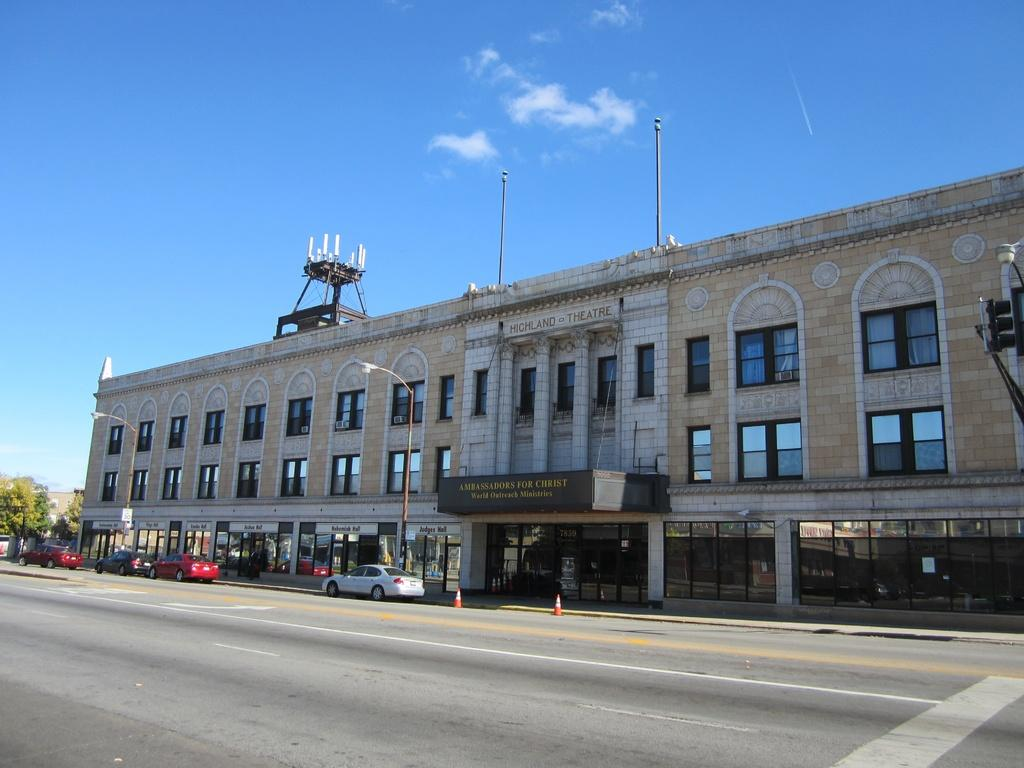What type of view is shown in the image? The image is an outside view. What can be seen on the road in the image? There are cars on the road in the image. What is visible in the background of the image? There is a building and trees in the background of the image. What is visible at the top of the image? The sky is visible at the top of the image. What type of vegetable is growing on the building in the image? There is no vegetable growing on the building in the image; it is a building with no visible vegetation. What material is the glass made of in the image? There is no glass present in the image. 